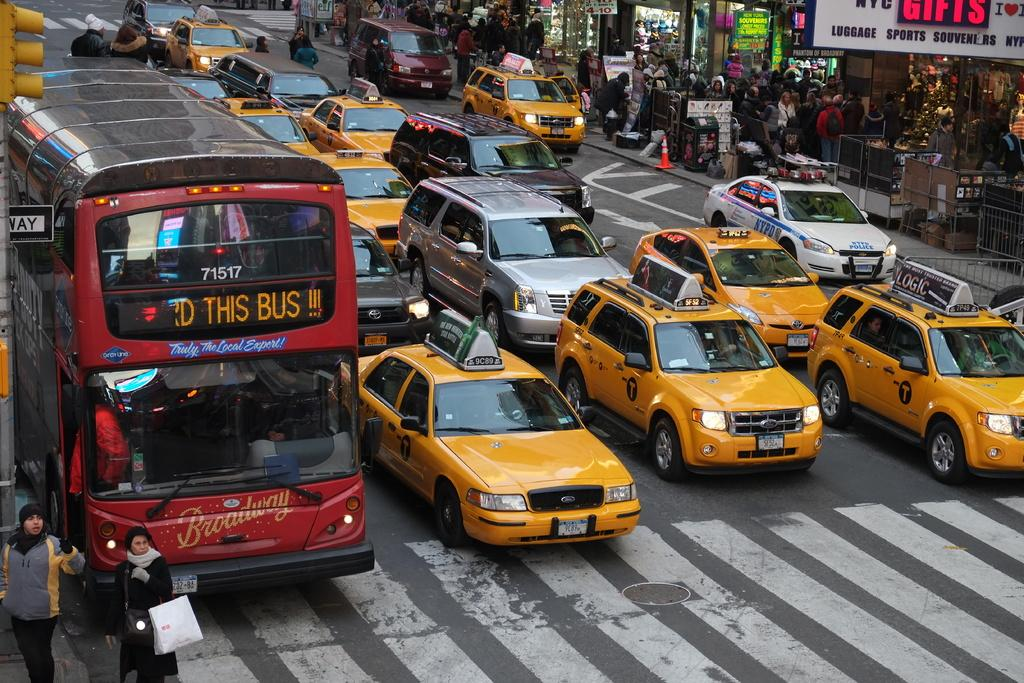<image>
Offer a succinct explanation of the picture presented. The front of the bus advertises Broadway as an experience. 